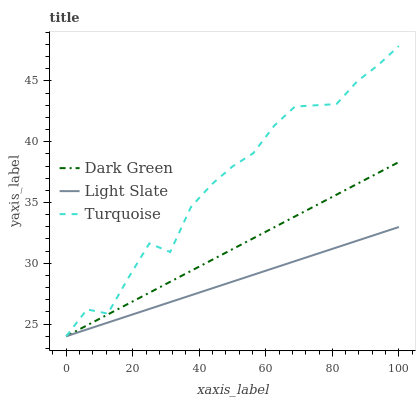Does Light Slate have the minimum area under the curve?
Answer yes or no. Yes. Does Turquoise have the maximum area under the curve?
Answer yes or no. Yes. Does Dark Green have the minimum area under the curve?
Answer yes or no. No. Does Dark Green have the maximum area under the curve?
Answer yes or no. No. Is Light Slate the smoothest?
Answer yes or no. Yes. Is Turquoise the roughest?
Answer yes or no. Yes. Is Dark Green the smoothest?
Answer yes or no. No. Is Dark Green the roughest?
Answer yes or no. No. Does Light Slate have the lowest value?
Answer yes or no. Yes. Does Turquoise have the highest value?
Answer yes or no. Yes. Does Dark Green have the highest value?
Answer yes or no. No. Does Turquoise intersect Light Slate?
Answer yes or no. Yes. Is Turquoise less than Light Slate?
Answer yes or no. No. Is Turquoise greater than Light Slate?
Answer yes or no. No. 